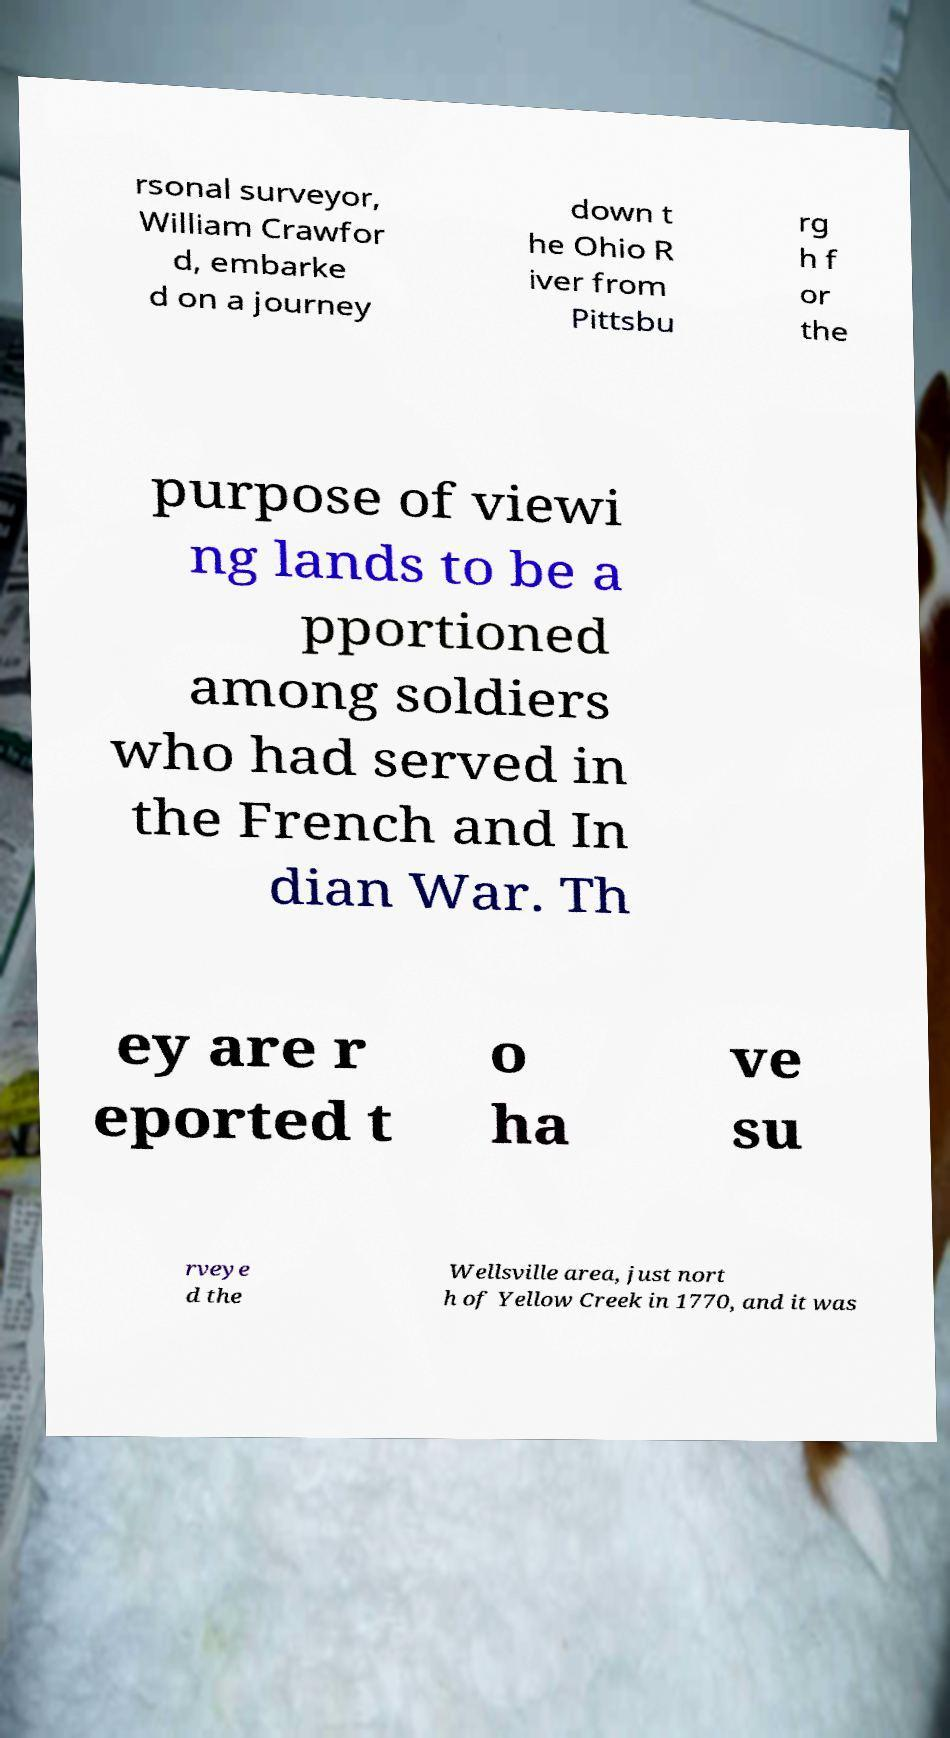There's text embedded in this image that I need extracted. Can you transcribe it verbatim? rsonal surveyor, William Crawfor d, embarke d on a journey down t he Ohio R iver from Pittsbu rg h f or the purpose of viewi ng lands to be a pportioned among soldiers who had served in the French and In dian War. Th ey are r eported t o ha ve su rveye d the Wellsville area, just nort h of Yellow Creek in 1770, and it was 